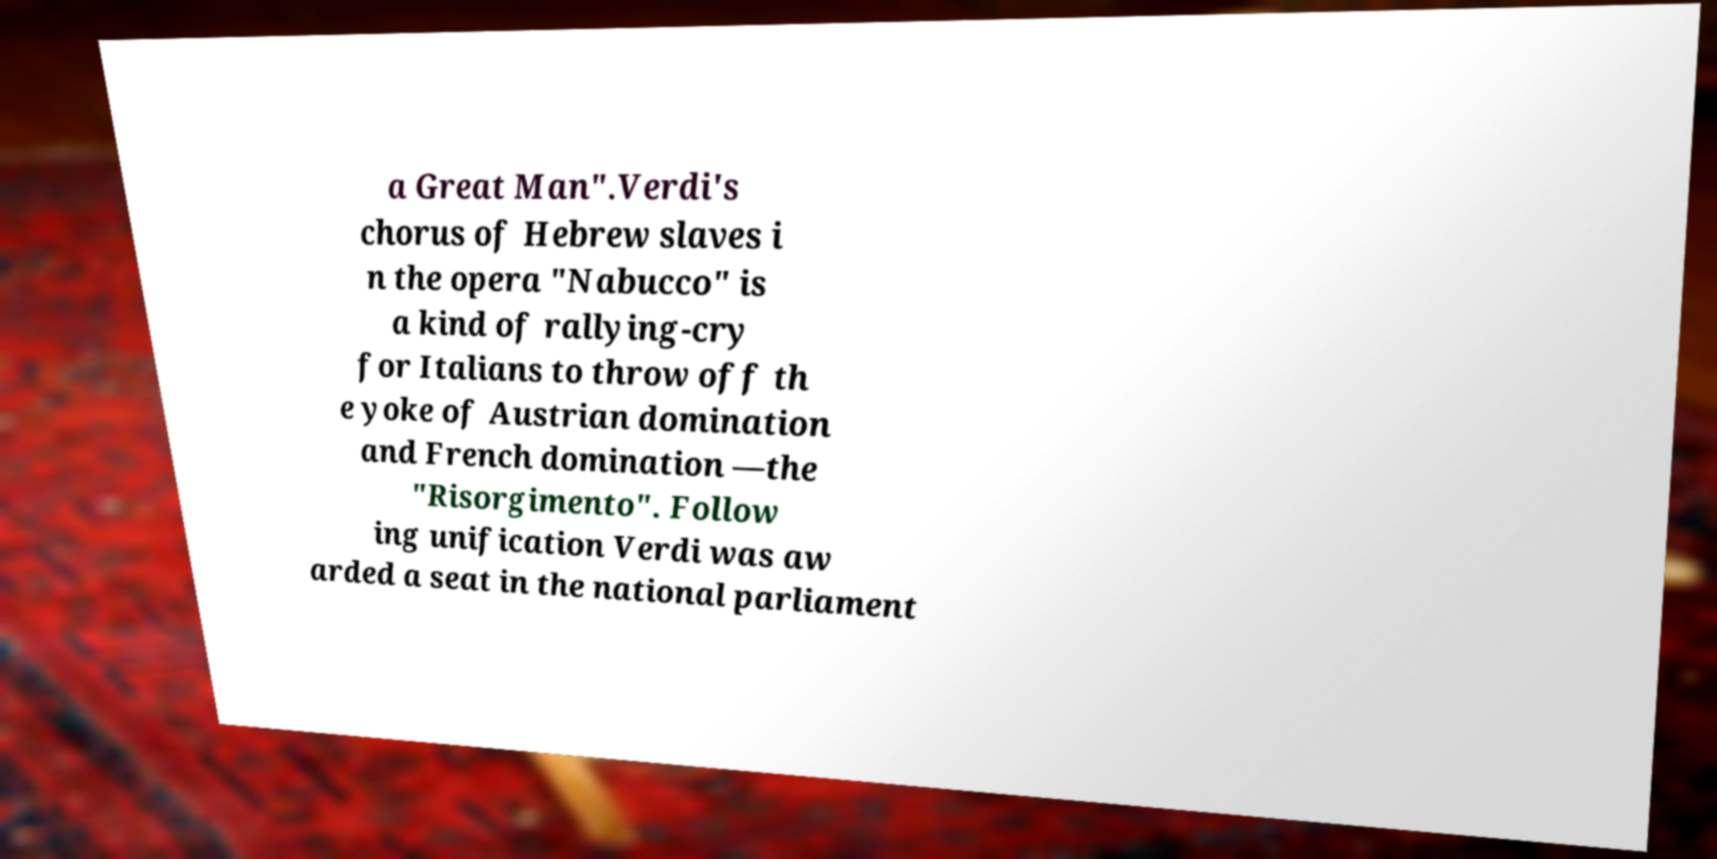I need the written content from this picture converted into text. Can you do that? a Great Man".Verdi's chorus of Hebrew slaves i n the opera "Nabucco" is a kind of rallying-cry for Italians to throw off th e yoke of Austrian domination and French domination —the "Risorgimento". Follow ing unification Verdi was aw arded a seat in the national parliament 